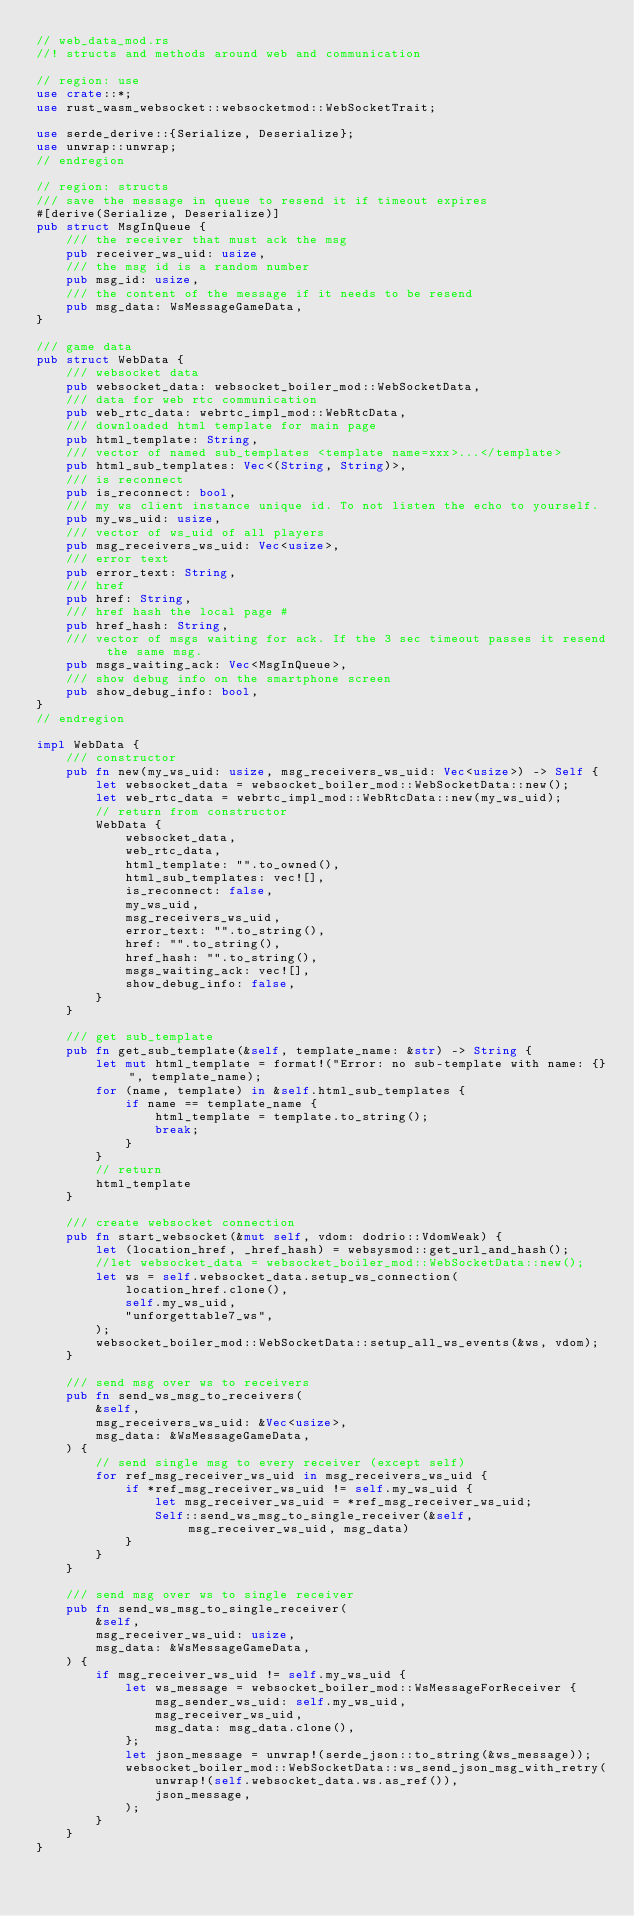Convert code to text. <code><loc_0><loc_0><loc_500><loc_500><_Rust_>// web_data_mod.rs
//! structs and methods around web and communication

// region: use
use crate::*;
use rust_wasm_websocket::websocketmod::WebSocketTrait;

use serde_derive::{Serialize, Deserialize};
use unwrap::unwrap;
// endregion

// region: structs
/// save the message in queue to resend it if timeout expires
#[derive(Serialize, Deserialize)]
pub struct MsgInQueue {
    /// the receiver that must ack the msg
    pub receiver_ws_uid: usize,
    /// the msg id is a random number
    pub msg_id: usize,
    /// the content of the message if it needs to be resend
    pub msg_data: WsMessageGameData,
}

/// game data
pub struct WebData {
    /// websocket data
    pub websocket_data: websocket_boiler_mod::WebSocketData,
    /// data for web rtc communication
    pub web_rtc_data: webrtc_impl_mod::WebRtcData,
    /// downloaded html template for main page
    pub html_template: String,
    /// vector of named sub_templates <template name=xxx>...</template>
    pub html_sub_templates: Vec<(String, String)>,
    /// is reconnect
    pub is_reconnect: bool,
    /// my ws client instance unique id. To not listen the echo to yourself.
    pub my_ws_uid: usize,
    /// vector of ws_uid of all players
    pub msg_receivers_ws_uid: Vec<usize>,
    /// error text
    pub error_text: String,
    /// href
    pub href: String,
    /// href hash the local page #
    pub href_hash: String,
    /// vector of msgs waiting for ack. If the 3 sec timeout passes it resend the same msg.
    pub msgs_waiting_ack: Vec<MsgInQueue>,
    /// show debug info on the smartphone screen
    pub show_debug_info: bool,
}
// endregion

impl WebData {
    /// constructor
    pub fn new(my_ws_uid: usize, msg_receivers_ws_uid: Vec<usize>) -> Self {
        let websocket_data = websocket_boiler_mod::WebSocketData::new();
        let web_rtc_data = webrtc_impl_mod::WebRtcData::new(my_ws_uid);
        // return from constructor
        WebData {
            websocket_data,
            web_rtc_data,
            html_template: "".to_owned(),
            html_sub_templates: vec![],
            is_reconnect: false,
            my_ws_uid,
            msg_receivers_ws_uid,
            error_text: "".to_string(),
            href: "".to_string(),
            href_hash: "".to_string(),
            msgs_waiting_ack: vec![],
            show_debug_info: false,
        }
    }

    /// get sub_template
    pub fn get_sub_template(&self, template_name: &str) -> String {
        let mut html_template = format!("Error: no sub-template with name: {}", template_name);
        for (name, template) in &self.html_sub_templates {
            if name == template_name {
                html_template = template.to_string();
                break;
            }
        }
        // return
        html_template
    }

    /// create websocket connection
    pub fn start_websocket(&mut self, vdom: dodrio::VdomWeak) {
        let (location_href, _href_hash) = websysmod::get_url_and_hash();
        //let websocket_data = websocket_boiler_mod::WebSocketData::new();
        let ws = self.websocket_data.setup_ws_connection(
            location_href.clone(),
            self.my_ws_uid,
            "unforgettable7_ws",
        );
        websocket_boiler_mod::WebSocketData::setup_all_ws_events(&ws, vdom);
    }

    /// send msg over ws to receivers
    pub fn send_ws_msg_to_receivers(
        &self,
        msg_receivers_ws_uid: &Vec<usize>,
        msg_data: &WsMessageGameData,
    ) {
        // send single msg to every receiver (except self)
        for ref_msg_receiver_ws_uid in msg_receivers_ws_uid {
            if *ref_msg_receiver_ws_uid != self.my_ws_uid {
                let msg_receiver_ws_uid = *ref_msg_receiver_ws_uid;
                Self::send_ws_msg_to_single_receiver(&self, msg_receiver_ws_uid, msg_data)
            }
        }
    }

    /// send msg over ws to single receiver
    pub fn send_ws_msg_to_single_receiver(
        &self,
        msg_receiver_ws_uid: usize,
        msg_data: &WsMessageGameData,
    ) {
        if msg_receiver_ws_uid != self.my_ws_uid {
            let ws_message = websocket_boiler_mod::WsMessageForReceiver {
                msg_sender_ws_uid: self.my_ws_uid,
                msg_receiver_ws_uid,
                msg_data: msg_data.clone(),
            };
            let json_message = unwrap!(serde_json::to_string(&ws_message));
            websocket_boiler_mod::WebSocketData::ws_send_json_msg_with_retry(
                unwrap!(self.websocket_data.ws.as_ref()),
                json_message,
            );
        }
    }
}
</code> 